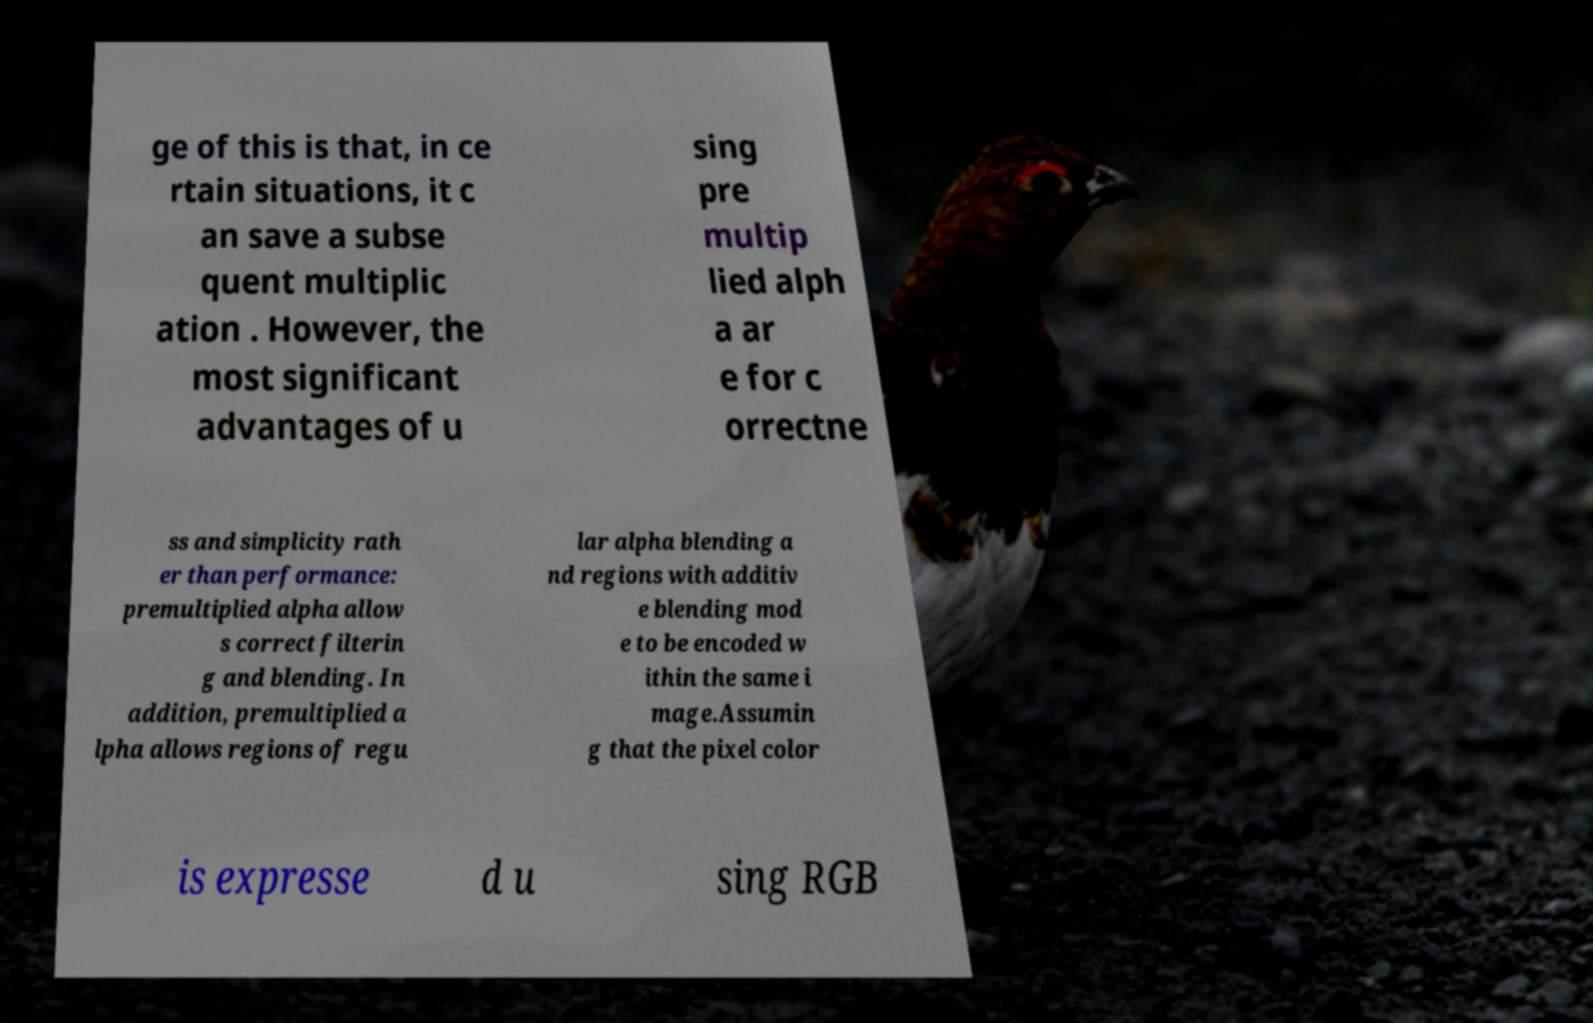Could you extract and type out the text from this image? ge of this is that, in ce rtain situations, it c an save a subse quent multiplic ation . However, the most significant advantages of u sing pre multip lied alph a ar e for c orrectne ss and simplicity rath er than performance: premultiplied alpha allow s correct filterin g and blending. In addition, premultiplied a lpha allows regions of regu lar alpha blending a nd regions with additiv e blending mod e to be encoded w ithin the same i mage.Assumin g that the pixel color is expresse d u sing RGB 